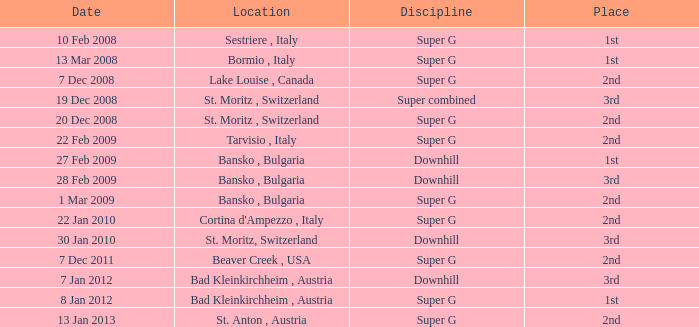What is the date of Super G in the 2010 season? 22 Jan 2010. 